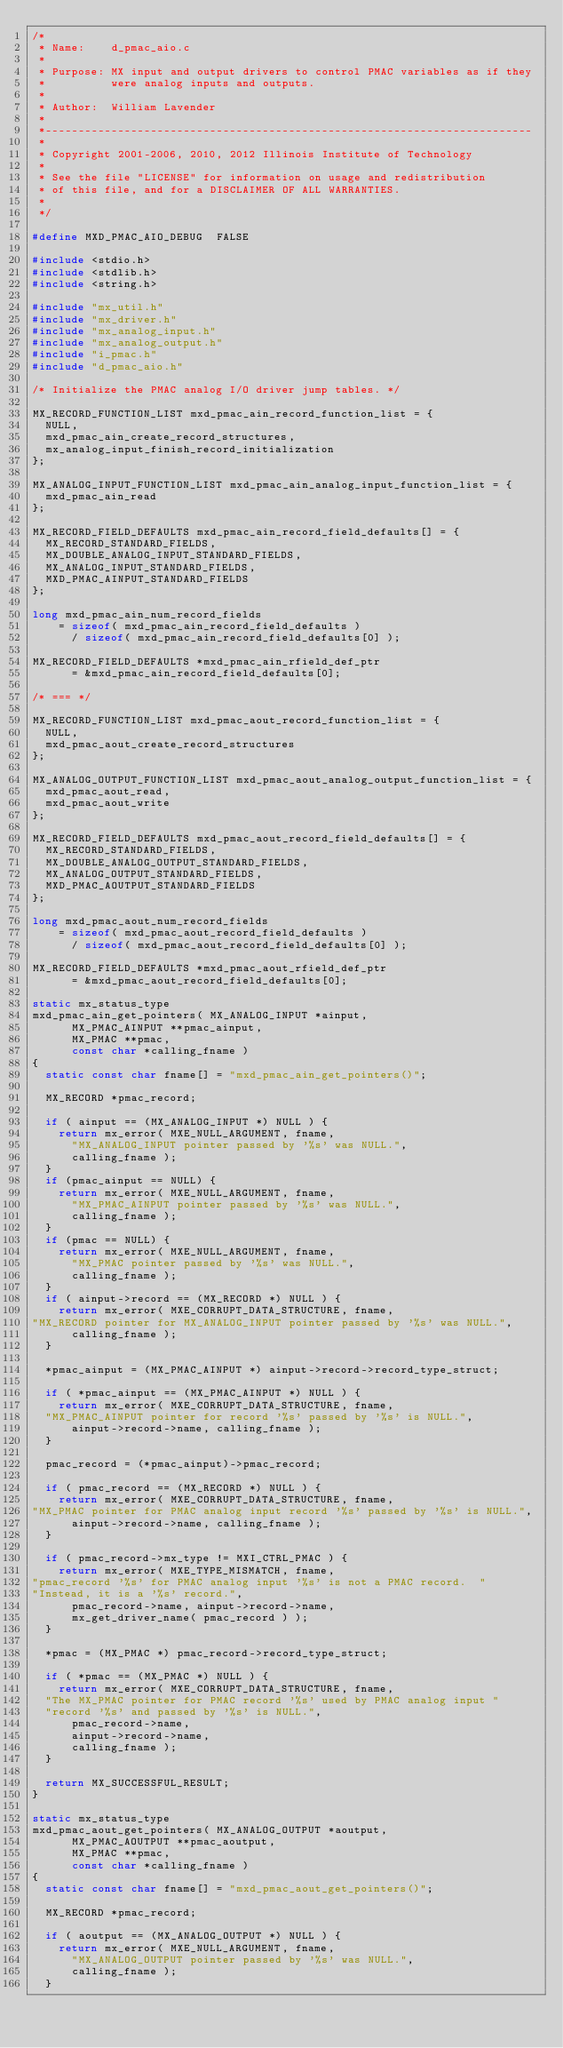<code> <loc_0><loc_0><loc_500><loc_500><_C_>/*
 * Name:    d_pmac_aio.c
 *
 * Purpose: MX input and output drivers to control PMAC variables as if they
 *          were analog inputs and outputs.
 *
 * Author:  William Lavender
 *
 *--------------------------------------------------------------------------
 *
 * Copyright 2001-2006, 2010, 2012 Illinois Institute of Technology
 *
 * See the file "LICENSE" for information on usage and redistribution
 * of this file, and for a DISCLAIMER OF ALL WARRANTIES.
 *
 */

#define MXD_PMAC_AIO_DEBUG	FALSE

#include <stdio.h>
#include <stdlib.h>
#include <string.h>

#include "mx_util.h"
#include "mx_driver.h"
#include "mx_analog_input.h"
#include "mx_analog_output.h"
#include "i_pmac.h"
#include "d_pmac_aio.h"

/* Initialize the PMAC analog I/O driver jump tables. */

MX_RECORD_FUNCTION_LIST mxd_pmac_ain_record_function_list = {
	NULL,
	mxd_pmac_ain_create_record_structures,
	mx_analog_input_finish_record_initialization
};

MX_ANALOG_INPUT_FUNCTION_LIST mxd_pmac_ain_analog_input_function_list = {
	mxd_pmac_ain_read
};

MX_RECORD_FIELD_DEFAULTS mxd_pmac_ain_record_field_defaults[] = {
	MX_RECORD_STANDARD_FIELDS,
	MX_DOUBLE_ANALOG_INPUT_STANDARD_FIELDS,
	MX_ANALOG_INPUT_STANDARD_FIELDS,
	MXD_PMAC_AINPUT_STANDARD_FIELDS
};

long mxd_pmac_ain_num_record_fields
		= sizeof( mxd_pmac_ain_record_field_defaults )
			/ sizeof( mxd_pmac_ain_record_field_defaults[0] );

MX_RECORD_FIELD_DEFAULTS *mxd_pmac_ain_rfield_def_ptr
			= &mxd_pmac_ain_record_field_defaults[0];

/* === */

MX_RECORD_FUNCTION_LIST mxd_pmac_aout_record_function_list = {
	NULL,
	mxd_pmac_aout_create_record_structures
};

MX_ANALOG_OUTPUT_FUNCTION_LIST mxd_pmac_aout_analog_output_function_list = {
	mxd_pmac_aout_read,
	mxd_pmac_aout_write
};

MX_RECORD_FIELD_DEFAULTS mxd_pmac_aout_record_field_defaults[] = {
	MX_RECORD_STANDARD_FIELDS,
	MX_DOUBLE_ANALOG_OUTPUT_STANDARD_FIELDS,
	MX_ANALOG_OUTPUT_STANDARD_FIELDS,
	MXD_PMAC_AOUTPUT_STANDARD_FIELDS
};

long mxd_pmac_aout_num_record_fields
		= sizeof( mxd_pmac_aout_record_field_defaults )
			/ sizeof( mxd_pmac_aout_record_field_defaults[0] );

MX_RECORD_FIELD_DEFAULTS *mxd_pmac_aout_rfield_def_ptr
			= &mxd_pmac_aout_record_field_defaults[0];

static mx_status_type
mxd_pmac_ain_get_pointers( MX_ANALOG_INPUT *ainput,
			MX_PMAC_AINPUT **pmac_ainput,
			MX_PMAC **pmac,
			const char *calling_fname )
{
	static const char fname[] = "mxd_pmac_ain_get_pointers()";

	MX_RECORD *pmac_record;

	if ( ainput == (MX_ANALOG_INPUT *) NULL ) {
		return mx_error( MXE_NULL_ARGUMENT, fname,
			"MX_ANALOG_INPUT pointer passed by '%s' was NULL.",
			calling_fname );
	}
	if (pmac_ainput == NULL) {
		return mx_error( MXE_NULL_ARGUMENT, fname,
			"MX_PMAC_AINPUT pointer passed by '%s' was NULL.",
			calling_fname );
	}
	if (pmac == NULL) {
		return mx_error( MXE_NULL_ARGUMENT, fname,
			"MX_PMAC pointer passed by '%s' was NULL.",
			calling_fname );
	}
	if ( ainput->record == (MX_RECORD *) NULL ) {
		return mx_error( MXE_CORRUPT_DATA_STRUCTURE, fname,
"MX_RECORD pointer for MX_ANALOG_INPUT pointer passed by '%s' was NULL.",
			calling_fname );
	}

	*pmac_ainput = (MX_PMAC_AINPUT *) ainput->record->record_type_struct;

	if ( *pmac_ainput == (MX_PMAC_AINPUT *) NULL ) {
		return mx_error( MXE_CORRUPT_DATA_STRUCTURE, fname,
	"MX_PMAC_AINPUT pointer for record '%s' passed by '%s' is NULL.",
			ainput->record->name, calling_fname );
	}

	pmac_record = (*pmac_ainput)->pmac_record;

	if ( pmac_record == (MX_RECORD *) NULL ) {
		return mx_error( MXE_CORRUPT_DATA_STRUCTURE, fname,
"MX_PMAC pointer for PMAC analog input record '%s' passed by '%s' is NULL.",
			ainput->record->name, calling_fname );
	}

	if ( pmac_record->mx_type != MXI_CTRL_PMAC ) {
		return mx_error( MXE_TYPE_MISMATCH, fname,
"pmac_record '%s' for PMAC analog input '%s' is not a PMAC record.  "
"Instead, it is a '%s' record.",
			pmac_record->name, ainput->record->name,
			mx_get_driver_name( pmac_record ) );
	}

	*pmac = (MX_PMAC *) pmac_record->record_type_struct;

	if ( *pmac == (MX_PMAC *) NULL ) {
		return mx_error( MXE_CORRUPT_DATA_STRUCTURE, fname,
	"The MX_PMAC pointer for PMAC record '%s' used by PMAC analog input "
	"record '%s' and passed by '%s' is NULL.",
			pmac_record->name,
			ainput->record->name,
			calling_fname );
	}

	return MX_SUCCESSFUL_RESULT;
}

static mx_status_type
mxd_pmac_aout_get_pointers( MX_ANALOG_OUTPUT *aoutput,
			MX_PMAC_AOUTPUT **pmac_aoutput,
			MX_PMAC **pmac,
			const char *calling_fname )
{
	static const char fname[] = "mxd_pmac_aout_get_pointers()";

	MX_RECORD *pmac_record;

	if ( aoutput == (MX_ANALOG_OUTPUT *) NULL ) {
		return mx_error( MXE_NULL_ARGUMENT, fname,
			"MX_ANALOG_OUTPUT pointer passed by '%s' was NULL.",
			calling_fname );
	}</code> 